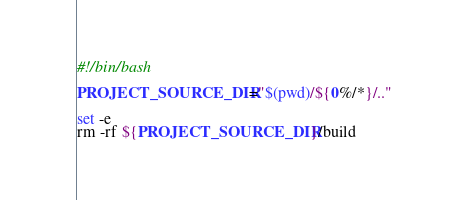<code> <loc_0><loc_0><loc_500><loc_500><_Bash_>#!/bin/bash

PROJECT_SOURCE_DIR="$(pwd)/${0%/*}/.."

set -e
rm -rf ${PROJECT_SOURCE_DIR}/build
</code> 